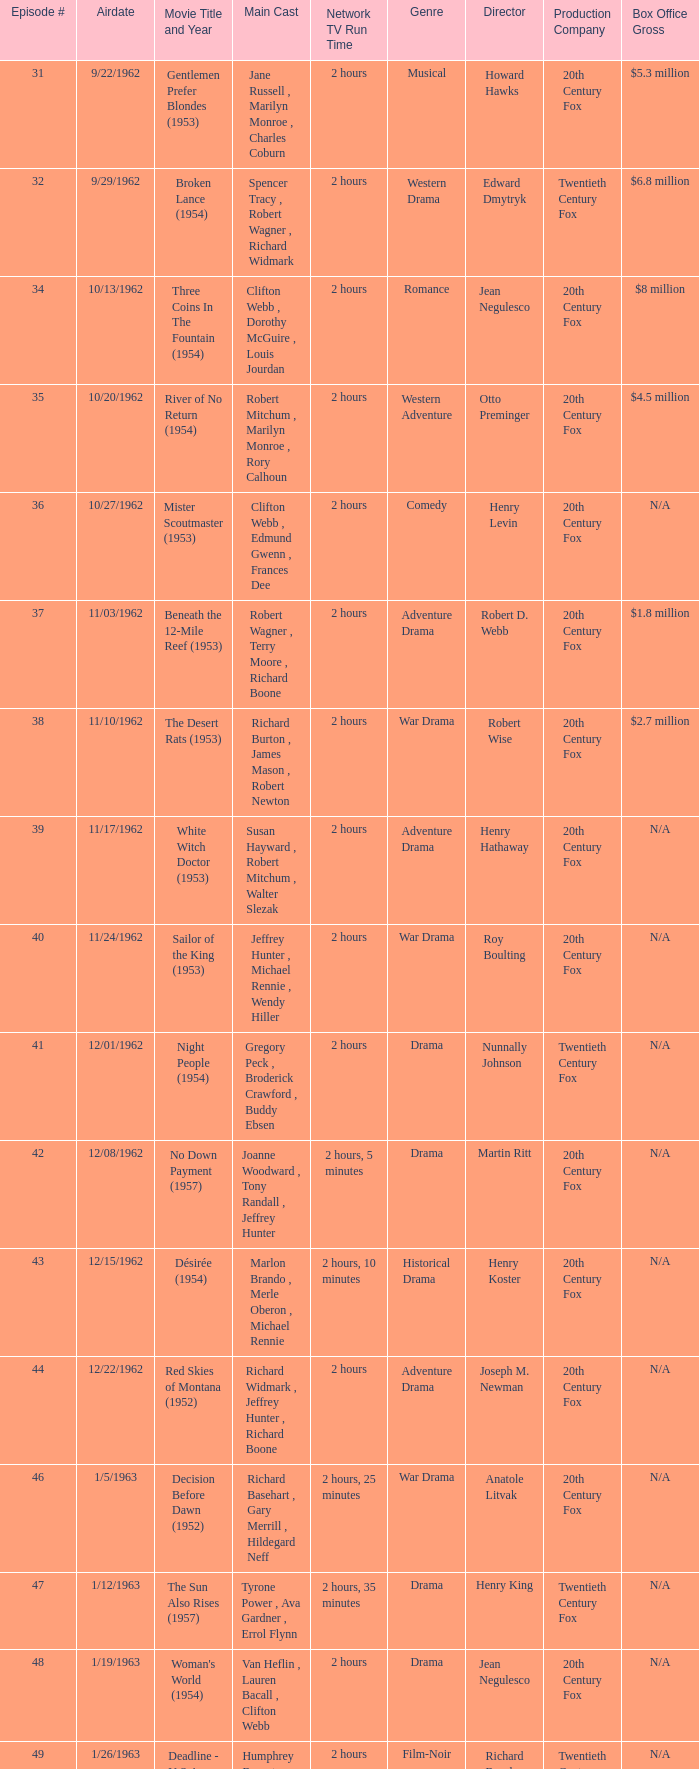Who was the cast on the 3/23/1963 episode? Dana Wynter , Mel Ferrer , Theodore Bikel. 